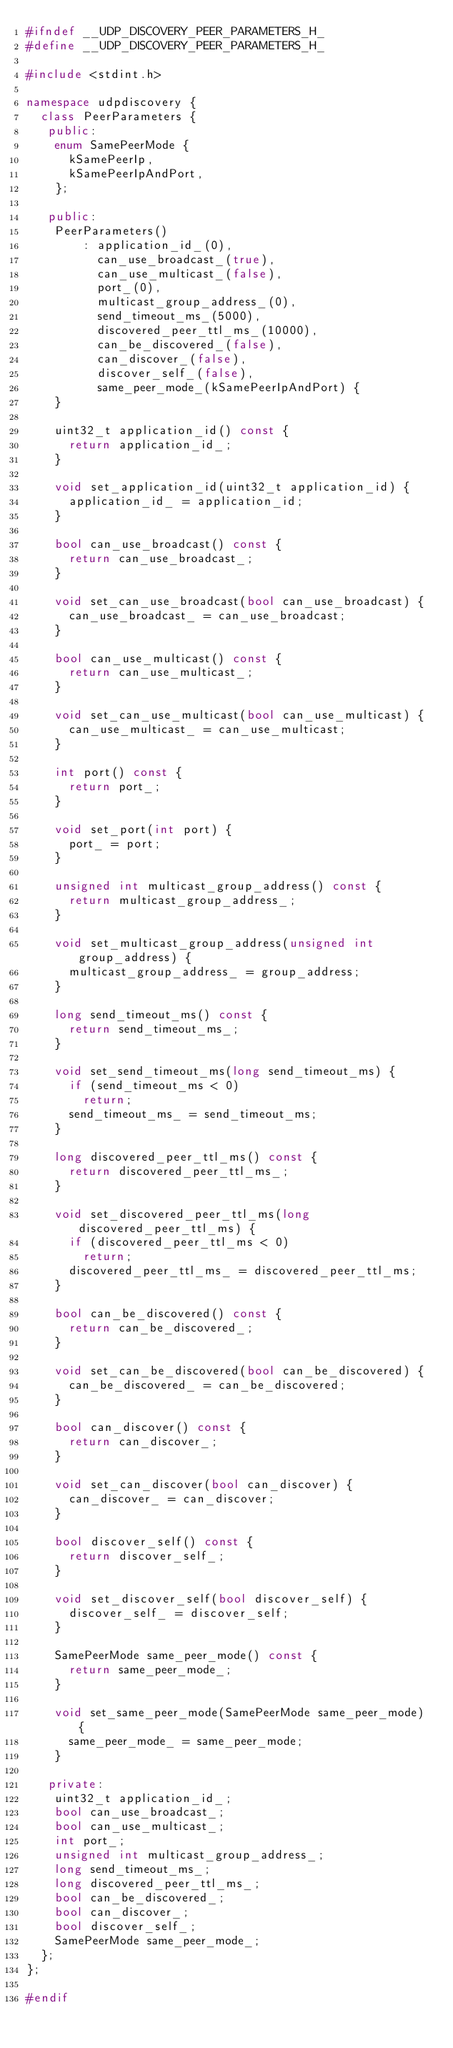Convert code to text. <code><loc_0><loc_0><loc_500><loc_500><_C++_>#ifndef __UDP_DISCOVERY_PEER_PARAMETERS_H_
#define __UDP_DISCOVERY_PEER_PARAMETERS_H_

#include <stdint.h>

namespace udpdiscovery {
  class PeerParameters {
   public:
    enum SamePeerMode {
      kSamePeerIp,
      kSamePeerIpAndPort,
    };

   public:
    PeerParameters()
        : application_id_(0),
          can_use_broadcast_(true),
          can_use_multicast_(false),
          port_(0),
          multicast_group_address_(0),
          send_timeout_ms_(5000),
          discovered_peer_ttl_ms_(10000),
          can_be_discovered_(false),
          can_discover_(false),
          discover_self_(false),
          same_peer_mode_(kSamePeerIpAndPort) {
    }

    uint32_t application_id() const {
      return application_id_;
    }

    void set_application_id(uint32_t application_id) {
      application_id_ = application_id;
    }

    bool can_use_broadcast() const {
      return can_use_broadcast_;
    }

    void set_can_use_broadcast(bool can_use_broadcast) {
      can_use_broadcast_ = can_use_broadcast;
    }

    bool can_use_multicast() const {
      return can_use_multicast_;
    }

    void set_can_use_multicast(bool can_use_multicast) {
      can_use_multicast_ = can_use_multicast;
    }

    int port() const {
      return port_;
    }

    void set_port(int port) {
      port_ = port;
    }

    unsigned int multicast_group_address() const {
      return multicast_group_address_;
    }

    void set_multicast_group_address(unsigned int group_address) {
      multicast_group_address_ = group_address;
    }

    long send_timeout_ms() const {
      return send_timeout_ms_;
    }

    void set_send_timeout_ms(long send_timeout_ms) {
      if (send_timeout_ms < 0)
        return;
      send_timeout_ms_ = send_timeout_ms;
    }

    long discovered_peer_ttl_ms() const {
      return discovered_peer_ttl_ms_;
    }

    void set_discovered_peer_ttl_ms(long discovered_peer_ttl_ms) {
      if (discovered_peer_ttl_ms < 0)
        return;
      discovered_peer_ttl_ms_ = discovered_peer_ttl_ms;
    }

    bool can_be_discovered() const {
      return can_be_discovered_;
    }

    void set_can_be_discovered(bool can_be_discovered) {
      can_be_discovered_ = can_be_discovered;
    }

    bool can_discover() const {
      return can_discover_;
    }

    void set_can_discover(bool can_discover) {
      can_discover_ = can_discover;
    }

    bool discover_self() const {
      return discover_self_;
    }

    void set_discover_self(bool discover_self) {
      discover_self_ = discover_self;
    }

    SamePeerMode same_peer_mode() const {
      return same_peer_mode_;
    }

    void set_same_peer_mode(SamePeerMode same_peer_mode) {
      same_peer_mode_ = same_peer_mode;
    }

   private:
    uint32_t application_id_;
    bool can_use_broadcast_;
    bool can_use_multicast_;
    int port_;
    unsigned int multicast_group_address_;
    long send_timeout_ms_;
    long discovered_peer_ttl_ms_;
    bool can_be_discovered_;
    bool can_discover_;
    bool discover_self_;
    SamePeerMode same_peer_mode_;
  };
};

#endif
</code> 